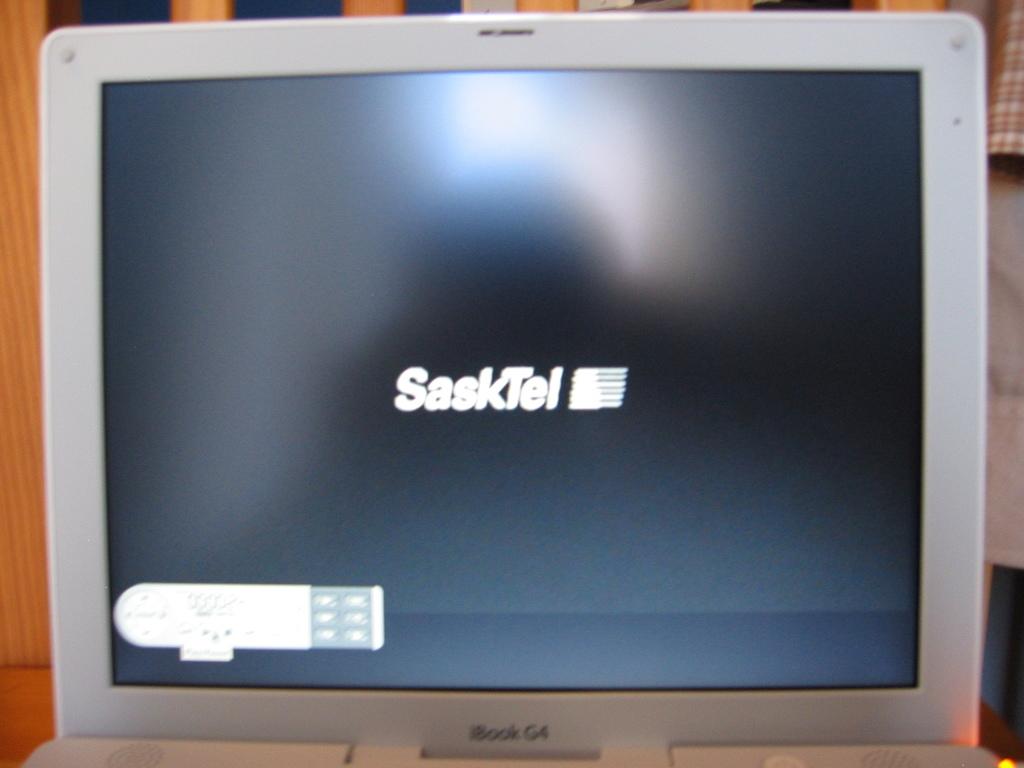What kind of laptop is this?
Ensure brevity in your answer.  Ibook g4. Whats on the screen?
Make the answer very short. Sasktel. 